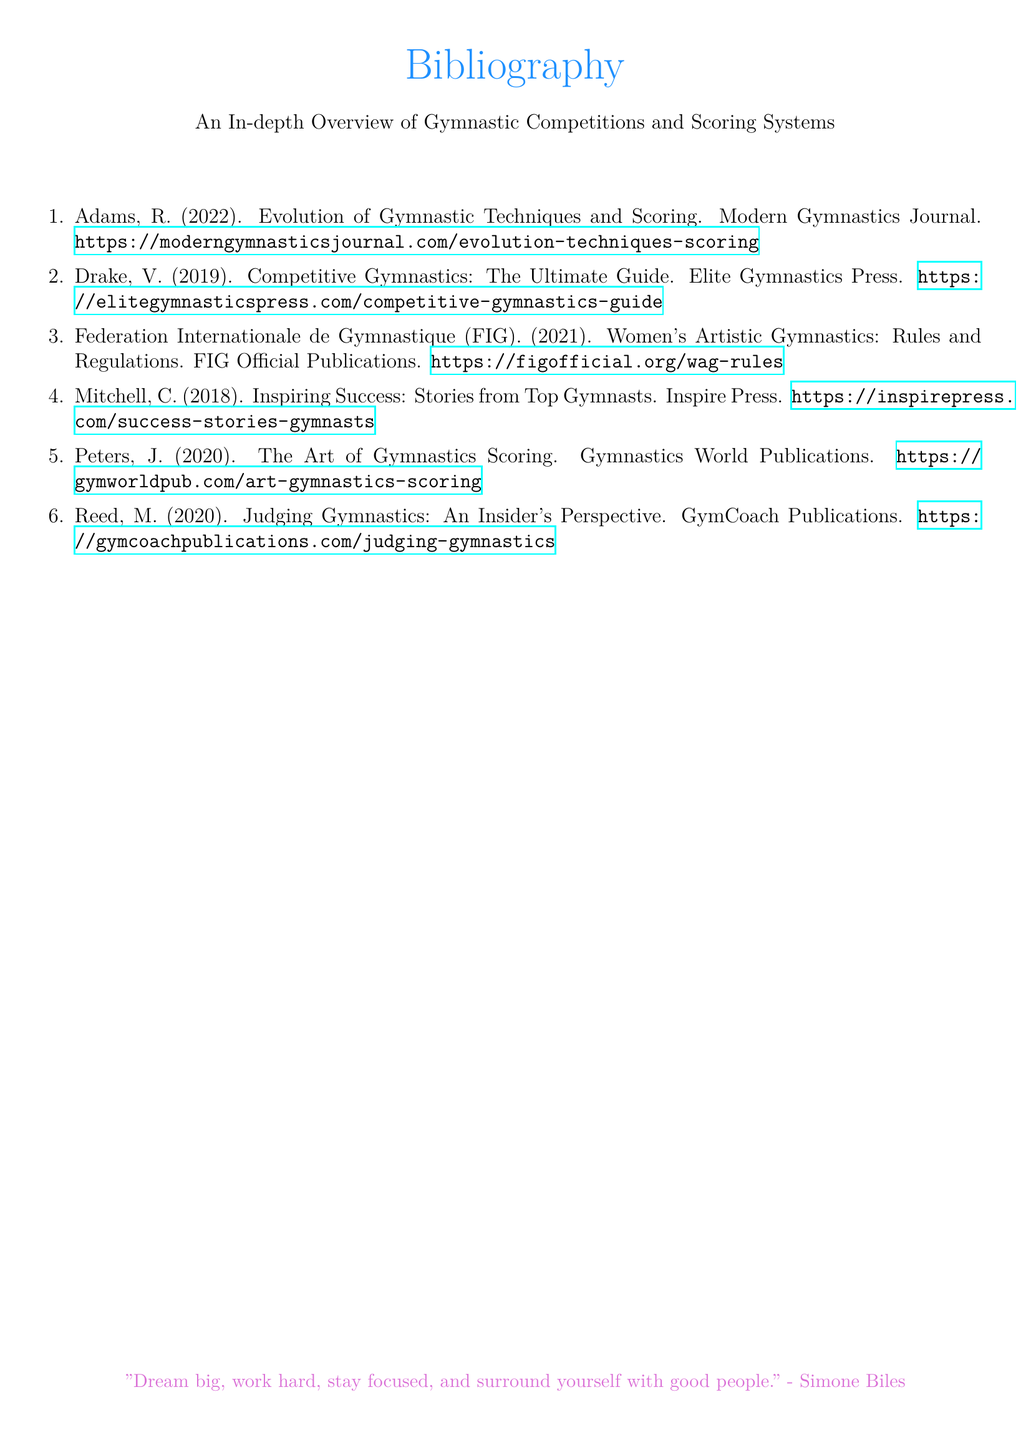What is the title of the document? The title of the document is mentioned prominently at the top of the rendered document.
Answer: An In-depth Overview of Gymnastic Competitions and Scoring Systems Who is the author of the work titled "Inspiring Success: Stories from Top Gymnasts"? The document lists authors along with their works, including the specified title.
Answer: Mitchell, C What year was "The Art of Gymnastics Scoring" published? The publication year is provided alongside each cited work in the document.
Answer: 2020 Which organization published the "Women's Artistic Gymnastics: Rules and Regulations"? The document specifies the publisher for the rules concerning women's artistic gymnastics.
Answer: Federation Internationale de Gymnastique (FIG) How many works are listed in the bibliography? The total number of entries can be counted in the enumerated list provided in the document.
Answer: 6 What is the color scheme used for the title in the bibliography? The title can be visually identified by its color in the rendered document.
Answer: Gymnast Who published "Competitive Gymnastics: The Ultimate Guide"? The document attributes each work to a specific publisher as part of the entries.
Answer: Elite Gymnastics Press What inspirational quote is included at the bottom of the document? The quote is included as a motivational note at the end of the bibliography.
Answer: "Dream big, work hard, stay focused, and surround yourself with good people." - Simone Biles What is the main font used in the document? The typeface for the entire document is specified at the beginning of the code.
Answer: Arial 